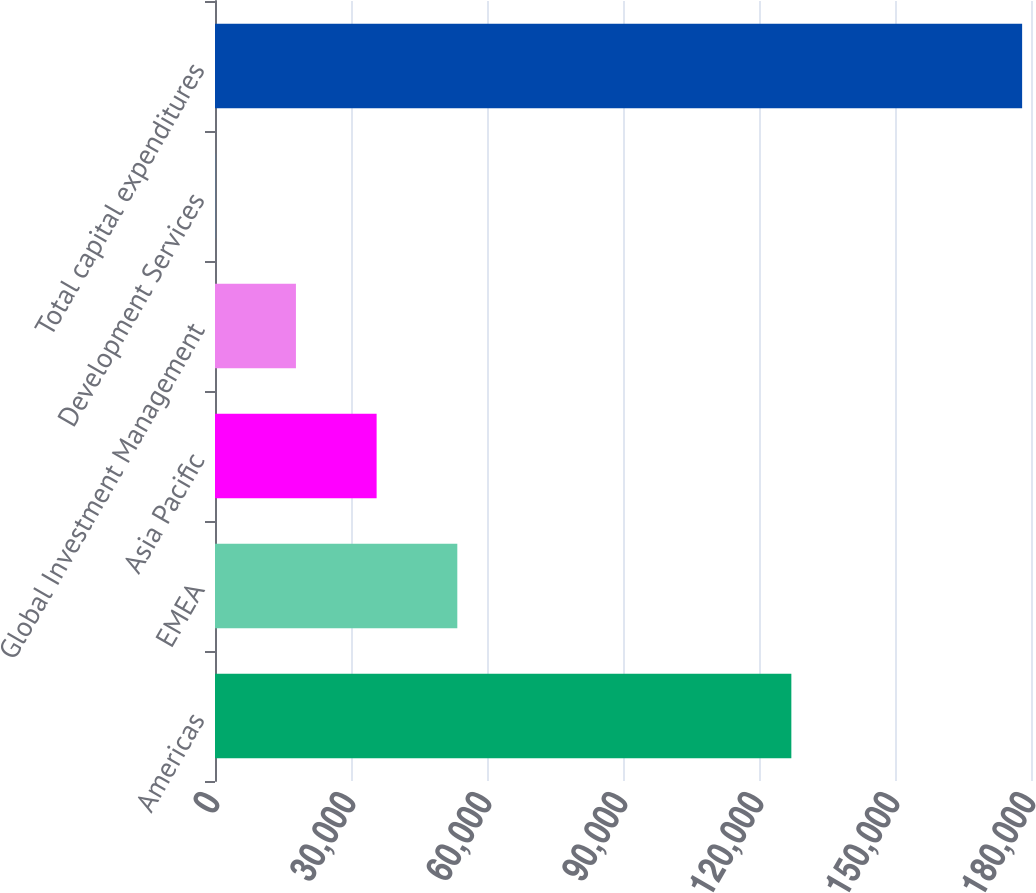<chart> <loc_0><loc_0><loc_500><loc_500><bar_chart><fcel>Americas<fcel>EMEA<fcel>Asia Pacific<fcel>Global Investment Management<fcel>Development Services<fcel>Total capital expenditures<nl><fcel>127135<fcel>53451.1<fcel>35652.4<fcel>17853.7<fcel>55<fcel>178042<nl></chart> 